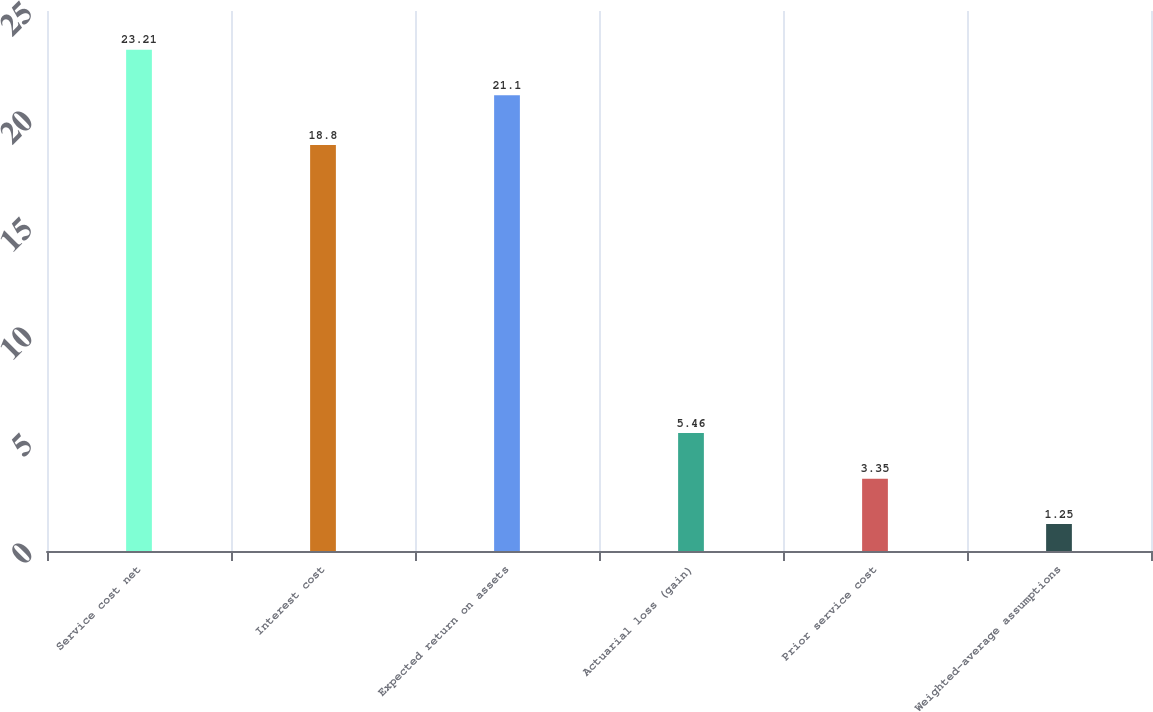<chart> <loc_0><loc_0><loc_500><loc_500><bar_chart><fcel>Service cost net<fcel>Interest cost<fcel>Expected return on assets<fcel>Actuarial loss (gain)<fcel>Prior service cost<fcel>Weighted-average assumptions<nl><fcel>23.21<fcel>18.8<fcel>21.1<fcel>5.46<fcel>3.35<fcel>1.25<nl></chart> 